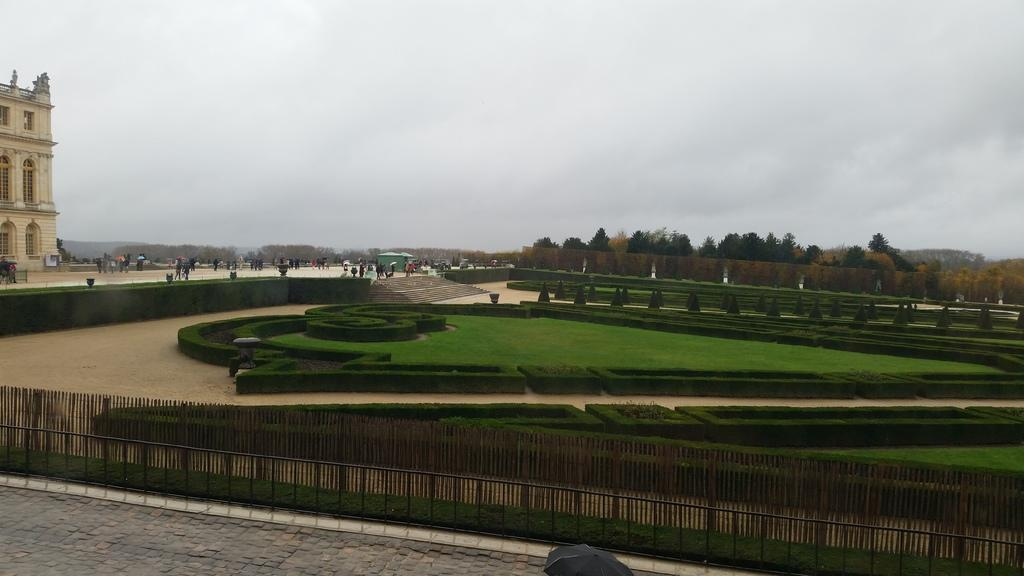What type of structure is visible in the image? There is a building in the image. What natural elements can be seen in the image? There are trees in the image. What type of barrier is present in the image? There is a metal fence in the image. Are there any people in the image? Yes, there are people standing in the image. How would you describe the weather based on the image? The sky is cloudy in the image. What object might be used for protection from the weather in the image? There is an umbrella in the image. What type of stew is being prepared by the people in the image? There is no indication of any stew being prepared in the image. What type of yam is visible in the image? There is no yam present in the image. 